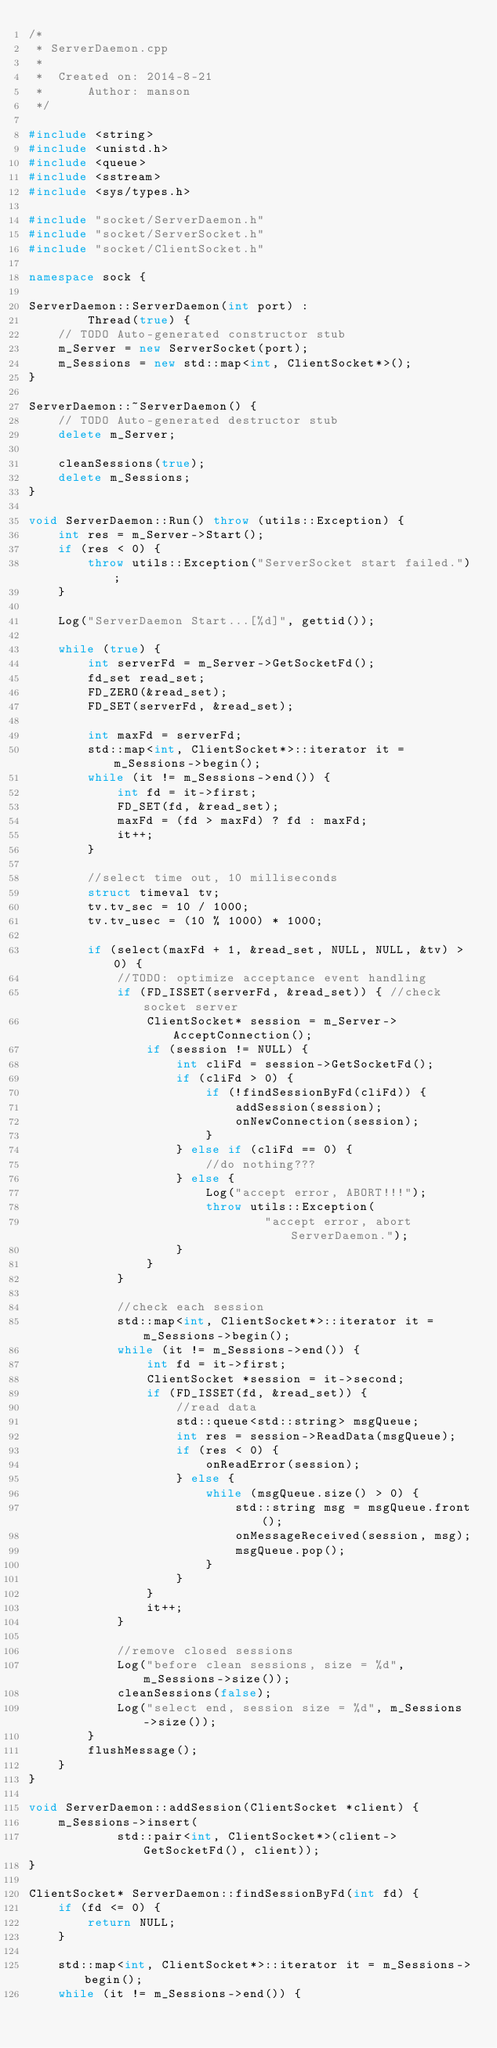<code> <loc_0><loc_0><loc_500><loc_500><_C++_>/*
 * ServerDaemon.cpp
 *
 *  Created on: 2014-8-21
 *      Author: manson
 */

#include <string>
#include <unistd.h>
#include <queue>
#include <sstream>
#include <sys/types.h>

#include "socket/ServerDaemon.h"
#include "socket/ServerSocket.h"
#include "socket/ClientSocket.h"

namespace sock {

ServerDaemon::ServerDaemon(int port) :
		Thread(true) {
	// TODO Auto-generated constructor stub
	m_Server = new ServerSocket(port);
	m_Sessions = new std::map<int, ClientSocket*>();
}

ServerDaemon::~ServerDaemon() {
	// TODO Auto-generated destructor stub
	delete m_Server;

	cleanSessions(true);
	delete m_Sessions;
}

void ServerDaemon::Run() throw (utils::Exception) {
	int res = m_Server->Start();
	if (res < 0) {
		throw utils::Exception("ServerSocket start failed.");
	}

	Log("ServerDaemon Start...[%d]", gettid());

	while (true) {
		int serverFd = m_Server->GetSocketFd();
		fd_set read_set;
		FD_ZERO(&read_set);
		FD_SET(serverFd, &read_set);

		int maxFd = serverFd;
		std::map<int, ClientSocket*>::iterator it = m_Sessions->begin();
		while (it != m_Sessions->end()) {
			int fd = it->first;
			FD_SET(fd, &read_set);
			maxFd = (fd > maxFd) ? fd : maxFd;
			it++;
		}

		//select time out, 10 milliseconds
		struct timeval tv;
		tv.tv_sec = 10 / 1000;
		tv.tv_usec = (10 % 1000) * 1000;

		if (select(maxFd + 1, &read_set, NULL, NULL, &tv) > 0) {
			//TODO: optimize acceptance event handling
			if (FD_ISSET(serverFd, &read_set)) { //check socket server
				ClientSocket* session = m_Server->AcceptConnection();
				if (session != NULL) {
					int cliFd = session->GetSocketFd();
					if (cliFd > 0) {
						if (!findSessionByFd(cliFd)) {
							addSession(session);
							onNewConnection(session);
						}
					} else if (cliFd == 0) {
						//do nothing???
					} else {
						Log("accept error, ABORT!!!");
						throw utils::Exception(
								"accept error, abort ServerDaemon.");
					}
				}
			}

			//check each session
			std::map<int, ClientSocket*>::iterator it = m_Sessions->begin();
			while (it != m_Sessions->end()) {
				int fd = it->first;
				ClientSocket *session = it->second;
				if (FD_ISSET(fd, &read_set)) {
					//read data
					std::queue<std::string> msgQueue;
					int res = session->ReadData(msgQueue);
					if (res < 0) {
						onReadError(session);
					} else {
						while (msgQueue.size() > 0) {
							std::string msg = msgQueue.front();
							onMessageReceived(session, msg);
							msgQueue.pop();
						}
					}
				}
				it++;
			}

			//remove closed sessions
			Log("before clean sessions, size = %d", m_Sessions->size());
			cleanSessions(false);
			Log("select end, session size = %d", m_Sessions->size());
		}
		flushMessage();
	}
}

void ServerDaemon::addSession(ClientSocket *client) {
	m_Sessions->insert(
			std::pair<int, ClientSocket*>(client->GetSocketFd(), client));
}

ClientSocket* ServerDaemon::findSessionByFd(int fd) {
	if (fd <= 0) {
		return NULL;
	}

	std::map<int, ClientSocket*>::iterator it = m_Sessions->begin();
	while (it != m_Sessions->end()) {</code> 